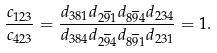Convert formula to latex. <formula><loc_0><loc_0><loc_500><loc_500>\frac { c _ { 1 2 3 } } { c _ { 4 2 3 } } = \frac { d _ { 3 8 1 } d _ { 2 \overline { 9 } 1 } d _ { 8 \overline { 9 } 4 } d _ { 2 3 4 } } { d _ { 3 8 4 } d _ { 2 \overline { 9 } 4 } d _ { 8 \overline { 9 } 1 } d _ { 2 3 1 } } = 1 .</formula> 